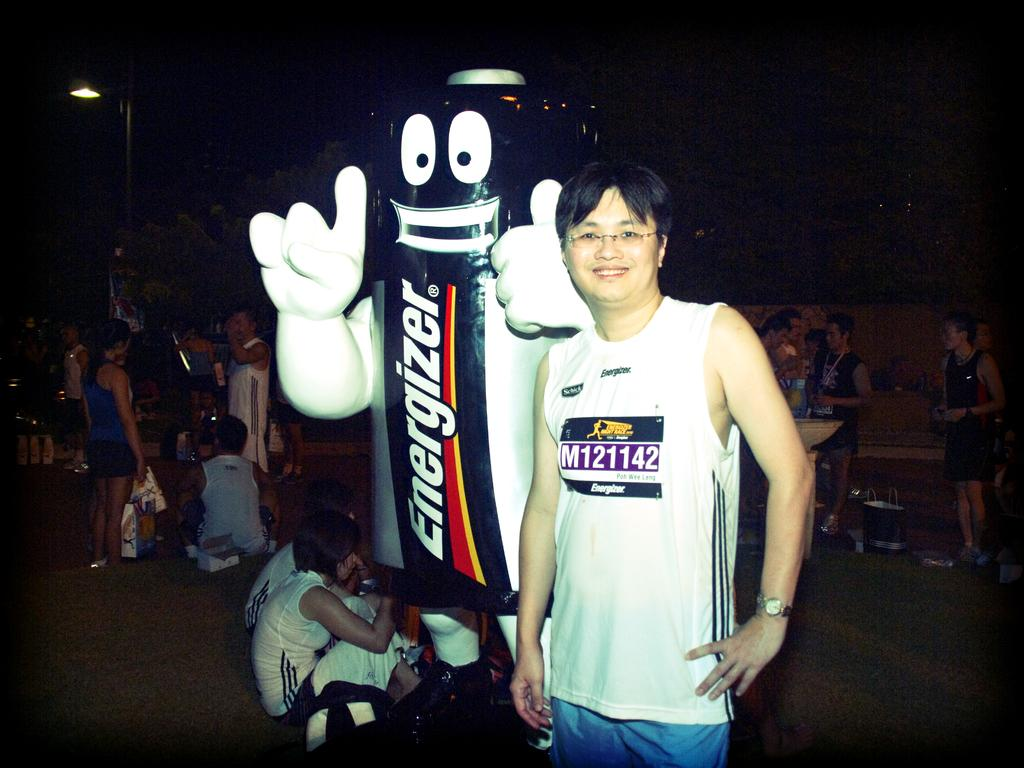<image>
Write a terse but informative summary of the picture. A person standing next to another person wearing an Energizer battery costume. 